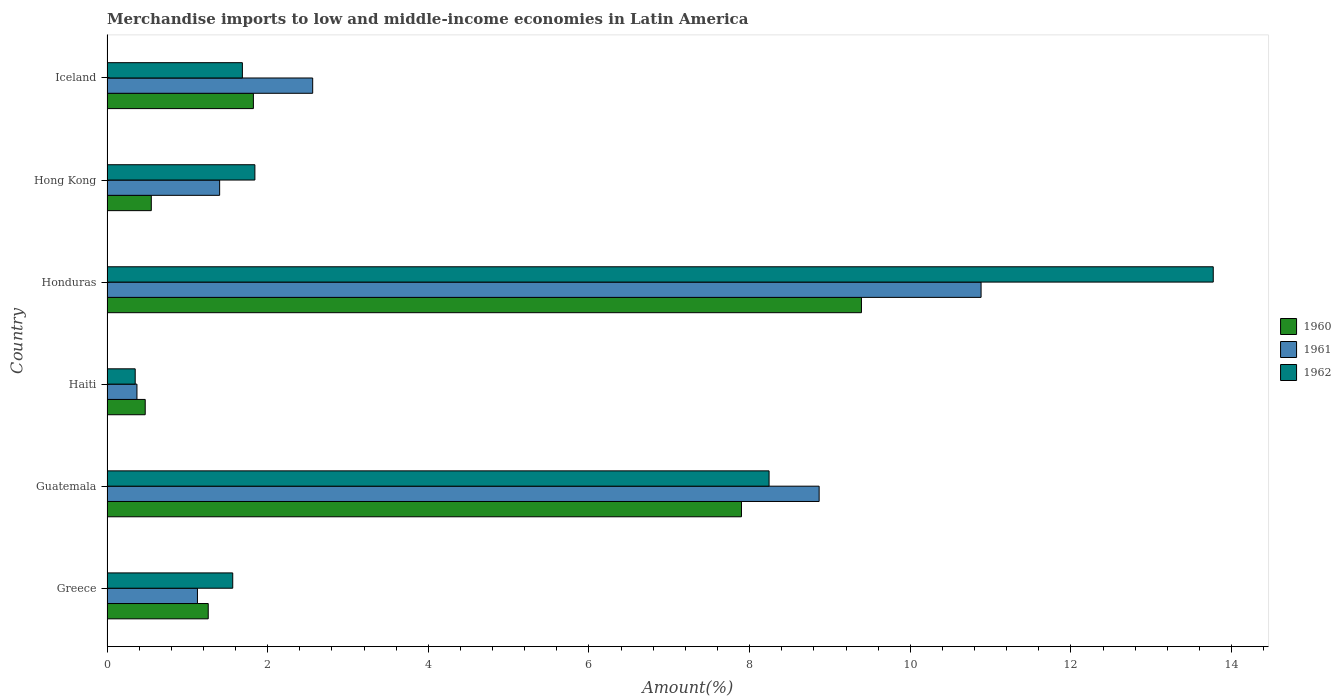How many different coloured bars are there?
Your answer should be compact. 3. How many groups of bars are there?
Provide a short and direct response. 6. How many bars are there on the 3rd tick from the top?
Your answer should be very brief. 3. How many bars are there on the 1st tick from the bottom?
Offer a terse response. 3. In how many cases, is the number of bars for a given country not equal to the number of legend labels?
Your answer should be compact. 0. What is the percentage of amount earned from merchandise imports in 1960 in Honduras?
Provide a short and direct response. 9.39. Across all countries, what is the maximum percentage of amount earned from merchandise imports in 1960?
Offer a very short reply. 9.39. Across all countries, what is the minimum percentage of amount earned from merchandise imports in 1960?
Offer a very short reply. 0.48. In which country was the percentage of amount earned from merchandise imports in 1960 maximum?
Offer a terse response. Honduras. In which country was the percentage of amount earned from merchandise imports in 1962 minimum?
Your answer should be compact. Haiti. What is the total percentage of amount earned from merchandise imports in 1962 in the graph?
Provide a short and direct response. 27.46. What is the difference between the percentage of amount earned from merchandise imports in 1962 in Greece and that in Iceland?
Your answer should be very brief. -0.12. What is the difference between the percentage of amount earned from merchandise imports in 1961 in Greece and the percentage of amount earned from merchandise imports in 1962 in Hong Kong?
Your answer should be compact. -0.72. What is the average percentage of amount earned from merchandise imports in 1961 per country?
Offer a very short reply. 4.2. What is the difference between the percentage of amount earned from merchandise imports in 1962 and percentage of amount earned from merchandise imports in 1961 in Hong Kong?
Make the answer very short. 0.44. What is the ratio of the percentage of amount earned from merchandise imports in 1962 in Haiti to that in Iceland?
Your response must be concise. 0.21. What is the difference between the highest and the second highest percentage of amount earned from merchandise imports in 1961?
Make the answer very short. 2.02. What is the difference between the highest and the lowest percentage of amount earned from merchandise imports in 1962?
Offer a very short reply. 13.42. In how many countries, is the percentage of amount earned from merchandise imports in 1960 greater than the average percentage of amount earned from merchandise imports in 1960 taken over all countries?
Provide a short and direct response. 2. Is it the case that in every country, the sum of the percentage of amount earned from merchandise imports in 1960 and percentage of amount earned from merchandise imports in 1961 is greater than the percentage of amount earned from merchandise imports in 1962?
Keep it short and to the point. Yes. Are all the bars in the graph horizontal?
Make the answer very short. Yes. How many countries are there in the graph?
Your response must be concise. 6. Are the values on the major ticks of X-axis written in scientific E-notation?
Your response must be concise. No. Does the graph contain any zero values?
Your answer should be compact. No. Does the graph contain grids?
Provide a succinct answer. No. What is the title of the graph?
Give a very brief answer. Merchandise imports to low and middle-income economies in Latin America. What is the label or title of the X-axis?
Offer a very short reply. Amount(%). What is the label or title of the Y-axis?
Offer a terse response. Country. What is the Amount(%) of 1960 in Greece?
Offer a terse response. 1.26. What is the Amount(%) of 1961 in Greece?
Your answer should be compact. 1.13. What is the Amount(%) of 1962 in Greece?
Make the answer very short. 1.57. What is the Amount(%) of 1960 in Guatemala?
Make the answer very short. 7.9. What is the Amount(%) in 1961 in Guatemala?
Your response must be concise. 8.87. What is the Amount(%) in 1962 in Guatemala?
Ensure brevity in your answer.  8.24. What is the Amount(%) in 1960 in Haiti?
Make the answer very short. 0.48. What is the Amount(%) in 1961 in Haiti?
Your answer should be compact. 0.37. What is the Amount(%) of 1962 in Haiti?
Ensure brevity in your answer.  0.35. What is the Amount(%) of 1960 in Honduras?
Offer a very short reply. 9.39. What is the Amount(%) of 1961 in Honduras?
Your response must be concise. 10.88. What is the Amount(%) of 1962 in Honduras?
Provide a short and direct response. 13.77. What is the Amount(%) of 1960 in Hong Kong?
Offer a terse response. 0.55. What is the Amount(%) in 1961 in Hong Kong?
Provide a short and direct response. 1.4. What is the Amount(%) in 1962 in Hong Kong?
Provide a succinct answer. 1.84. What is the Amount(%) of 1960 in Iceland?
Ensure brevity in your answer.  1.82. What is the Amount(%) in 1961 in Iceland?
Your answer should be very brief. 2.56. What is the Amount(%) of 1962 in Iceland?
Your answer should be very brief. 1.69. Across all countries, what is the maximum Amount(%) in 1960?
Provide a succinct answer. 9.39. Across all countries, what is the maximum Amount(%) in 1961?
Your answer should be compact. 10.88. Across all countries, what is the maximum Amount(%) in 1962?
Keep it short and to the point. 13.77. Across all countries, what is the minimum Amount(%) in 1960?
Provide a succinct answer. 0.48. Across all countries, what is the minimum Amount(%) of 1961?
Provide a short and direct response. 0.37. Across all countries, what is the minimum Amount(%) of 1962?
Provide a succinct answer. 0.35. What is the total Amount(%) of 1960 in the graph?
Offer a terse response. 21.4. What is the total Amount(%) of 1961 in the graph?
Make the answer very short. 25.21. What is the total Amount(%) in 1962 in the graph?
Provide a short and direct response. 27.46. What is the difference between the Amount(%) in 1960 in Greece and that in Guatemala?
Ensure brevity in your answer.  -6.64. What is the difference between the Amount(%) in 1961 in Greece and that in Guatemala?
Provide a short and direct response. -7.74. What is the difference between the Amount(%) of 1962 in Greece and that in Guatemala?
Ensure brevity in your answer.  -6.68. What is the difference between the Amount(%) of 1960 in Greece and that in Haiti?
Keep it short and to the point. 0.78. What is the difference between the Amount(%) of 1961 in Greece and that in Haiti?
Your response must be concise. 0.75. What is the difference between the Amount(%) of 1962 in Greece and that in Haiti?
Your answer should be compact. 1.21. What is the difference between the Amount(%) in 1960 in Greece and that in Honduras?
Your answer should be compact. -8.13. What is the difference between the Amount(%) of 1961 in Greece and that in Honduras?
Your answer should be compact. -9.76. What is the difference between the Amount(%) of 1962 in Greece and that in Honduras?
Your response must be concise. -12.21. What is the difference between the Amount(%) of 1960 in Greece and that in Hong Kong?
Your answer should be very brief. 0.71. What is the difference between the Amount(%) in 1961 in Greece and that in Hong Kong?
Your answer should be very brief. -0.28. What is the difference between the Amount(%) of 1962 in Greece and that in Hong Kong?
Your answer should be compact. -0.28. What is the difference between the Amount(%) in 1960 in Greece and that in Iceland?
Provide a succinct answer. -0.56. What is the difference between the Amount(%) of 1961 in Greece and that in Iceland?
Give a very brief answer. -1.43. What is the difference between the Amount(%) of 1962 in Greece and that in Iceland?
Offer a very short reply. -0.12. What is the difference between the Amount(%) in 1960 in Guatemala and that in Haiti?
Make the answer very short. 7.42. What is the difference between the Amount(%) in 1961 in Guatemala and that in Haiti?
Give a very brief answer. 8.49. What is the difference between the Amount(%) in 1962 in Guatemala and that in Haiti?
Provide a short and direct response. 7.89. What is the difference between the Amount(%) in 1960 in Guatemala and that in Honduras?
Offer a terse response. -1.49. What is the difference between the Amount(%) in 1961 in Guatemala and that in Honduras?
Keep it short and to the point. -2.02. What is the difference between the Amount(%) in 1962 in Guatemala and that in Honduras?
Offer a very short reply. -5.53. What is the difference between the Amount(%) in 1960 in Guatemala and that in Hong Kong?
Provide a short and direct response. 7.35. What is the difference between the Amount(%) of 1961 in Guatemala and that in Hong Kong?
Offer a terse response. 7.46. What is the difference between the Amount(%) of 1962 in Guatemala and that in Hong Kong?
Provide a short and direct response. 6.4. What is the difference between the Amount(%) in 1960 in Guatemala and that in Iceland?
Provide a succinct answer. 6.08. What is the difference between the Amount(%) of 1961 in Guatemala and that in Iceland?
Make the answer very short. 6.3. What is the difference between the Amount(%) of 1962 in Guatemala and that in Iceland?
Offer a very short reply. 6.56. What is the difference between the Amount(%) in 1960 in Haiti and that in Honduras?
Provide a short and direct response. -8.92. What is the difference between the Amount(%) in 1961 in Haiti and that in Honduras?
Offer a very short reply. -10.51. What is the difference between the Amount(%) of 1962 in Haiti and that in Honduras?
Provide a succinct answer. -13.42. What is the difference between the Amount(%) in 1960 in Haiti and that in Hong Kong?
Your answer should be very brief. -0.08. What is the difference between the Amount(%) in 1961 in Haiti and that in Hong Kong?
Make the answer very short. -1.03. What is the difference between the Amount(%) in 1962 in Haiti and that in Hong Kong?
Provide a short and direct response. -1.49. What is the difference between the Amount(%) of 1960 in Haiti and that in Iceland?
Give a very brief answer. -1.35. What is the difference between the Amount(%) of 1961 in Haiti and that in Iceland?
Ensure brevity in your answer.  -2.19. What is the difference between the Amount(%) in 1962 in Haiti and that in Iceland?
Offer a very short reply. -1.33. What is the difference between the Amount(%) of 1960 in Honduras and that in Hong Kong?
Provide a short and direct response. 8.84. What is the difference between the Amount(%) of 1961 in Honduras and that in Hong Kong?
Your response must be concise. 9.48. What is the difference between the Amount(%) of 1962 in Honduras and that in Hong Kong?
Offer a very short reply. 11.93. What is the difference between the Amount(%) in 1960 in Honduras and that in Iceland?
Give a very brief answer. 7.57. What is the difference between the Amount(%) in 1961 in Honduras and that in Iceland?
Provide a short and direct response. 8.32. What is the difference between the Amount(%) in 1962 in Honduras and that in Iceland?
Make the answer very short. 12.09. What is the difference between the Amount(%) in 1960 in Hong Kong and that in Iceland?
Give a very brief answer. -1.27. What is the difference between the Amount(%) of 1961 in Hong Kong and that in Iceland?
Offer a terse response. -1.16. What is the difference between the Amount(%) in 1962 in Hong Kong and that in Iceland?
Give a very brief answer. 0.16. What is the difference between the Amount(%) of 1960 in Greece and the Amount(%) of 1961 in Guatemala?
Offer a terse response. -7.61. What is the difference between the Amount(%) in 1960 in Greece and the Amount(%) in 1962 in Guatemala?
Offer a terse response. -6.98. What is the difference between the Amount(%) in 1961 in Greece and the Amount(%) in 1962 in Guatemala?
Ensure brevity in your answer.  -7.12. What is the difference between the Amount(%) of 1960 in Greece and the Amount(%) of 1961 in Haiti?
Your response must be concise. 0.89. What is the difference between the Amount(%) in 1960 in Greece and the Amount(%) in 1962 in Haiti?
Provide a short and direct response. 0.91. What is the difference between the Amount(%) of 1961 in Greece and the Amount(%) of 1962 in Haiti?
Your answer should be compact. 0.77. What is the difference between the Amount(%) of 1960 in Greece and the Amount(%) of 1961 in Honduras?
Ensure brevity in your answer.  -9.62. What is the difference between the Amount(%) of 1960 in Greece and the Amount(%) of 1962 in Honduras?
Your answer should be very brief. -12.51. What is the difference between the Amount(%) of 1961 in Greece and the Amount(%) of 1962 in Honduras?
Offer a terse response. -12.65. What is the difference between the Amount(%) in 1960 in Greece and the Amount(%) in 1961 in Hong Kong?
Provide a succinct answer. -0.14. What is the difference between the Amount(%) of 1960 in Greece and the Amount(%) of 1962 in Hong Kong?
Your response must be concise. -0.58. What is the difference between the Amount(%) in 1961 in Greece and the Amount(%) in 1962 in Hong Kong?
Your response must be concise. -0.71. What is the difference between the Amount(%) of 1960 in Greece and the Amount(%) of 1961 in Iceland?
Offer a terse response. -1.3. What is the difference between the Amount(%) of 1960 in Greece and the Amount(%) of 1962 in Iceland?
Keep it short and to the point. -0.43. What is the difference between the Amount(%) of 1961 in Greece and the Amount(%) of 1962 in Iceland?
Keep it short and to the point. -0.56. What is the difference between the Amount(%) in 1960 in Guatemala and the Amount(%) in 1961 in Haiti?
Keep it short and to the point. 7.53. What is the difference between the Amount(%) in 1960 in Guatemala and the Amount(%) in 1962 in Haiti?
Give a very brief answer. 7.55. What is the difference between the Amount(%) of 1961 in Guatemala and the Amount(%) of 1962 in Haiti?
Give a very brief answer. 8.51. What is the difference between the Amount(%) of 1960 in Guatemala and the Amount(%) of 1961 in Honduras?
Offer a terse response. -2.98. What is the difference between the Amount(%) in 1960 in Guatemala and the Amount(%) in 1962 in Honduras?
Your answer should be very brief. -5.87. What is the difference between the Amount(%) in 1961 in Guatemala and the Amount(%) in 1962 in Honduras?
Your answer should be compact. -4.91. What is the difference between the Amount(%) of 1960 in Guatemala and the Amount(%) of 1961 in Hong Kong?
Your answer should be compact. 6.5. What is the difference between the Amount(%) of 1960 in Guatemala and the Amount(%) of 1962 in Hong Kong?
Keep it short and to the point. 6.06. What is the difference between the Amount(%) in 1961 in Guatemala and the Amount(%) in 1962 in Hong Kong?
Your answer should be compact. 7.02. What is the difference between the Amount(%) of 1960 in Guatemala and the Amount(%) of 1961 in Iceland?
Offer a terse response. 5.34. What is the difference between the Amount(%) of 1960 in Guatemala and the Amount(%) of 1962 in Iceland?
Ensure brevity in your answer.  6.21. What is the difference between the Amount(%) of 1961 in Guatemala and the Amount(%) of 1962 in Iceland?
Make the answer very short. 7.18. What is the difference between the Amount(%) of 1960 in Haiti and the Amount(%) of 1961 in Honduras?
Provide a succinct answer. -10.41. What is the difference between the Amount(%) of 1960 in Haiti and the Amount(%) of 1962 in Honduras?
Give a very brief answer. -13.3. What is the difference between the Amount(%) of 1961 in Haiti and the Amount(%) of 1962 in Honduras?
Give a very brief answer. -13.4. What is the difference between the Amount(%) in 1960 in Haiti and the Amount(%) in 1961 in Hong Kong?
Provide a short and direct response. -0.93. What is the difference between the Amount(%) in 1960 in Haiti and the Amount(%) in 1962 in Hong Kong?
Ensure brevity in your answer.  -1.37. What is the difference between the Amount(%) of 1961 in Haiti and the Amount(%) of 1962 in Hong Kong?
Ensure brevity in your answer.  -1.47. What is the difference between the Amount(%) of 1960 in Haiti and the Amount(%) of 1961 in Iceland?
Ensure brevity in your answer.  -2.08. What is the difference between the Amount(%) of 1960 in Haiti and the Amount(%) of 1962 in Iceland?
Keep it short and to the point. -1.21. What is the difference between the Amount(%) of 1961 in Haiti and the Amount(%) of 1962 in Iceland?
Give a very brief answer. -1.31. What is the difference between the Amount(%) of 1960 in Honduras and the Amount(%) of 1961 in Hong Kong?
Your answer should be very brief. 7.99. What is the difference between the Amount(%) of 1960 in Honduras and the Amount(%) of 1962 in Hong Kong?
Provide a succinct answer. 7.55. What is the difference between the Amount(%) of 1961 in Honduras and the Amount(%) of 1962 in Hong Kong?
Provide a succinct answer. 9.04. What is the difference between the Amount(%) in 1960 in Honduras and the Amount(%) in 1961 in Iceland?
Ensure brevity in your answer.  6.83. What is the difference between the Amount(%) of 1960 in Honduras and the Amount(%) of 1962 in Iceland?
Make the answer very short. 7.71. What is the difference between the Amount(%) in 1961 in Honduras and the Amount(%) in 1962 in Iceland?
Make the answer very short. 9.2. What is the difference between the Amount(%) of 1960 in Hong Kong and the Amount(%) of 1961 in Iceland?
Provide a short and direct response. -2.01. What is the difference between the Amount(%) in 1960 in Hong Kong and the Amount(%) in 1962 in Iceland?
Your response must be concise. -1.13. What is the difference between the Amount(%) in 1961 in Hong Kong and the Amount(%) in 1962 in Iceland?
Give a very brief answer. -0.28. What is the average Amount(%) of 1960 per country?
Keep it short and to the point. 3.57. What is the average Amount(%) in 1961 per country?
Provide a short and direct response. 4.2. What is the average Amount(%) of 1962 per country?
Your answer should be compact. 4.58. What is the difference between the Amount(%) in 1960 and Amount(%) in 1961 in Greece?
Keep it short and to the point. 0.13. What is the difference between the Amount(%) in 1960 and Amount(%) in 1962 in Greece?
Keep it short and to the point. -0.3. What is the difference between the Amount(%) of 1961 and Amount(%) of 1962 in Greece?
Offer a terse response. -0.44. What is the difference between the Amount(%) of 1960 and Amount(%) of 1961 in Guatemala?
Your answer should be very brief. -0.97. What is the difference between the Amount(%) of 1960 and Amount(%) of 1962 in Guatemala?
Make the answer very short. -0.34. What is the difference between the Amount(%) in 1961 and Amount(%) in 1962 in Guatemala?
Give a very brief answer. 0.62. What is the difference between the Amount(%) of 1960 and Amount(%) of 1961 in Haiti?
Offer a terse response. 0.1. What is the difference between the Amount(%) in 1960 and Amount(%) in 1962 in Haiti?
Provide a succinct answer. 0.12. What is the difference between the Amount(%) of 1961 and Amount(%) of 1962 in Haiti?
Keep it short and to the point. 0.02. What is the difference between the Amount(%) in 1960 and Amount(%) in 1961 in Honduras?
Your response must be concise. -1.49. What is the difference between the Amount(%) in 1960 and Amount(%) in 1962 in Honduras?
Your response must be concise. -4.38. What is the difference between the Amount(%) in 1961 and Amount(%) in 1962 in Honduras?
Your response must be concise. -2.89. What is the difference between the Amount(%) in 1960 and Amount(%) in 1961 in Hong Kong?
Ensure brevity in your answer.  -0.85. What is the difference between the Amount(%) of 1960 and Amount(%) of 1962 in Hong Kong?
Make the answer very short. -1.29. What is the difference between the Amount(%) of 1961 and Amount(%) of 1962 in Hong Kong?
Make the answer very short. -0.44. What is the difference between the Amount(%) in 1960 and Amount(%) in 1961 in Iceland?
Your answer should be compact. -0.74. What is the difference between the Amount(%) in 1960 and Amount(%) in 1962 in Iceland?
Your answer should be very brief. 0.14. What is the difference between the Amount(%) of 1961 and Amount(%) of 1962 in Iceland?
Offer a very short reply. 0.88. What is the ratio of the Amount(%) in 1960 in Greece to that in Guatemala?
Give a very brief answer. 0.16. What is the ratio of the Amount(%) of 1961 in Greece to that in Guatemala?
Offer a terse response. 0.13. What is the ratio of the Amount(%) of 1962 in Greece to that in Guatemala?
Offer a terse response. 0.19. What is the ratio of the Amount(%) in 1960 in Greece to that in Haiti?
Provide a succinct answer. 2.65. What is the ratio of the Amount(%) in 1961 in Greece to that in Haiti?
Offer a very short reply. 3.02. What is the ratio of the Amount(%) of 1962 in Greece to that in Haiti?
Make the answer very short. 4.46. What is the ratio of the Amount(%) of 1960 in Greece to that in Honduras?
Offer a very short reply. 0.13. What is the ratio of the Amount(%) of 1961 in Greece to that in Honduras?
Your answer should be very brief. 0.1. What is the ratio of the Amount(%) of 1962 in Greece to that in Honduras?
Your answer should be compact. 0.11. What is the ratio of the Amount(%) of 1960 in Greece to that in Hong Kong?
Your response must be concise. 2.29. What is the ratio of the Amount(%) of 1961 in Greece to that in Hong Kong?
Give a very brief answer. 0.8. What is the ratio of the Amount(%) in 1962 in Greece to that in Hong Kong?
Provide a short and direct response. 0.85. What is the ratio of the Amount(%) of 1960 in Greece to that in Iceland?
Offer a terse response. 0.69. What is the ratio of the Amount(%) of 1961 in Greece to that in Iceland?
Your response must be concise. 0.44. What is the ratio of the Amount(%) of 1962 in Greece to that in Iceland?
Your answer should be very brief. 0.93. What is the ratio of the Amount(%) in 1960 in Guatemala to that in Haiti?
Provide a succinct answer. 16.61. What is the ratio of the Amount(%) of 1961 in Guatemala to that in Haiti?
Your answer should be compact. 23.77. What is the ratio of the Amount(%) of 1962 in Guatemala to that in Haiti?
Keep it short and to the point. 23.47. What is the ratio of the Amount(%) of 1960 in Guatemala to that in Honduras?
Your response must be concise. 0.84. What is the ratio of the Amount(%) in 1961 in Guatemala to that in Honduras?
Provide a short and direct response. 0.81. What is the ratio of the Amount(%) of 1962 in Guatemala to that in Honduras?
Offer a terse response. 0.6. What is the ratio of the Amount(%) in 1960 in Guatemala to that in Hong Kong?
Offer a terse response. 14.33. What is the ratio of the Amount(%) in 1961 in Guatemala to that in Hong Kong?
Give a very brief answer. 6.32. What is the ratio of the Amount(%) in 1962 in Guatemala to that in Hong Kong?
Give a very brief answer. 4.48. What is the ratio of the Amount(%) of 1960 in Guatemala to that in Iceland?
Give a very brief answer. 4.33. What is the ratio of the Amount(%) of 1961 in Guatemala to that in Iceland?
Keep it short and to the point. 3.46. What is the ratio of the Amount(%) of 1962 in Guatemala to that in Iceland?
Offer a terse response. 4.89. What is the ratio of the Amount(%) of 1960 in Haiti to that in Honduras?
Your answer should be compact. 0.05. What is the ratio of the Amount(%) in 1961 in Haiti to that in Honduras?
Offer a terse response. 0.03. What is the ratio of the Amount(%) in 1962 in Haiti to that in Honduras?
Provide a succinct answer. 0.03. What is the ratio of the Amount(%) of 1960 in Haiti to that in Hong Kong?
Make the answer very short. 0.86. What is the ratio of the Amount(%) in 1961 in Haiti to that in Hong Kong?
Keep it short and to the point. 0.27. What is the ratio of the Amount(%) in 1962 in Haiti to that in Hong Kong?
Provide a succinct answer. 0.19. What is the ratio of the Amount(%) in 1960 in Haiti to that in Iceland?
Your response must be concise. 0.26. What is the ratio of the Amount(%) of 1961 in Haiti to that in Iceland?
Ensure brevity in your answer.  0.15. What is the ratio of the Amount(%) in 1962 in Haiti to that in Iceland?
Ensure brevity in your answer.  0.21. What is the ratio of the Amount(%) of 1960 in Honduras to that in Hong Kong?
Make the answer very short. 17.03. What is the ratio of the Amount(%) in 1961 in Honduras to that in Hong Kong?
Keep it short and to the point. 7.76. What is the ratio of the Amount(%) in 1962 in Honduras to that in Hong Kong?
Ensure brevity in your answer.  7.48. What is the ratio of the Amount(%) of 1960 in Honduras to that in Iceland?
Provide a short and direct response. 5.15. What is the ratio of the Amount(%) in 1961 in Honduras to that in Iceland?
Make the answer very short. 4.25. What is the ratio of the Amount(%) of 1962 in Honduras to that in Iceland?
Keep it short and to the point. 8.17. What is the ratio of the Amount(%) of 1960 in Hong Kong to that in Iceland?
Your answer should be compact. 0.3. What is the ratio of the Amount(%) in 1961 in Hong Kong to that in Iceland?
Provide a succinct answer. 0.55. What is the ratio of the Amount(%) of 1962 in Hong Kong to that in Iceland?
Provide a short and direct response. 1.09. What is the difference between the highest and the second highest Amount(%) in 1960?
Provide a short and direct response. 1.49. What is the difference between the highest and the second highest Amount(%) in 1961?
Ensure brevity in your answer.  2.02. What is the difference between the highest and the second highest Amount(%) in 1962?
Your answer should be very brief. 5.53. What is the difference between the highest and the lowest Amount(%) of 1960?
Give a very brief answer. 8.92. What is the difference between the highest and the lowest Amount(%) in 1961?
Your answer should be compact. 10.51. What is the difference between the highest and the lowest Amount(%) of 1962?
Provide a succinct answer. 13.42. 